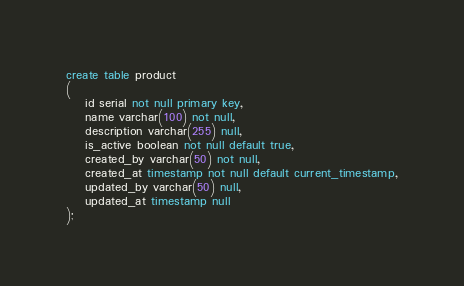<code> <loc_0><loc_0><loc_500><loc_500><_SQL_>create table product
(
	id serial not null primary key,
	name varchar(100) not null,
	description varchar(255) null,
	is_active boolean not null default true,
	created_by varchar(50) not null,
	created_at timestamp not null default current_timestamp,
	updated_by varchar(50) null,
	updated_at timestamp null
);</code> 